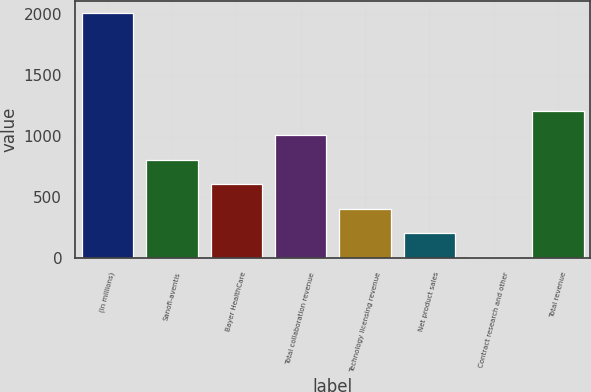<chart> <loc_0><loc_0><loc_500><loc_500><bar_chart><fcel>(In millions)<fcel>Sanofi-aventis<fcel>Bayer HealthCare<fcel>Total collaboration revenue<fcel>Technology licensing revenue<fcel>Net product sales<fcel>Contract research and other<fcel>Total revenue<nl><fcel>2009<fcel>807.44<fcel>607.18<fcel>1007.7<fcel>406.92<fcel>206.66<fcel>6.4<fcel>1207.96<nl></chart> 